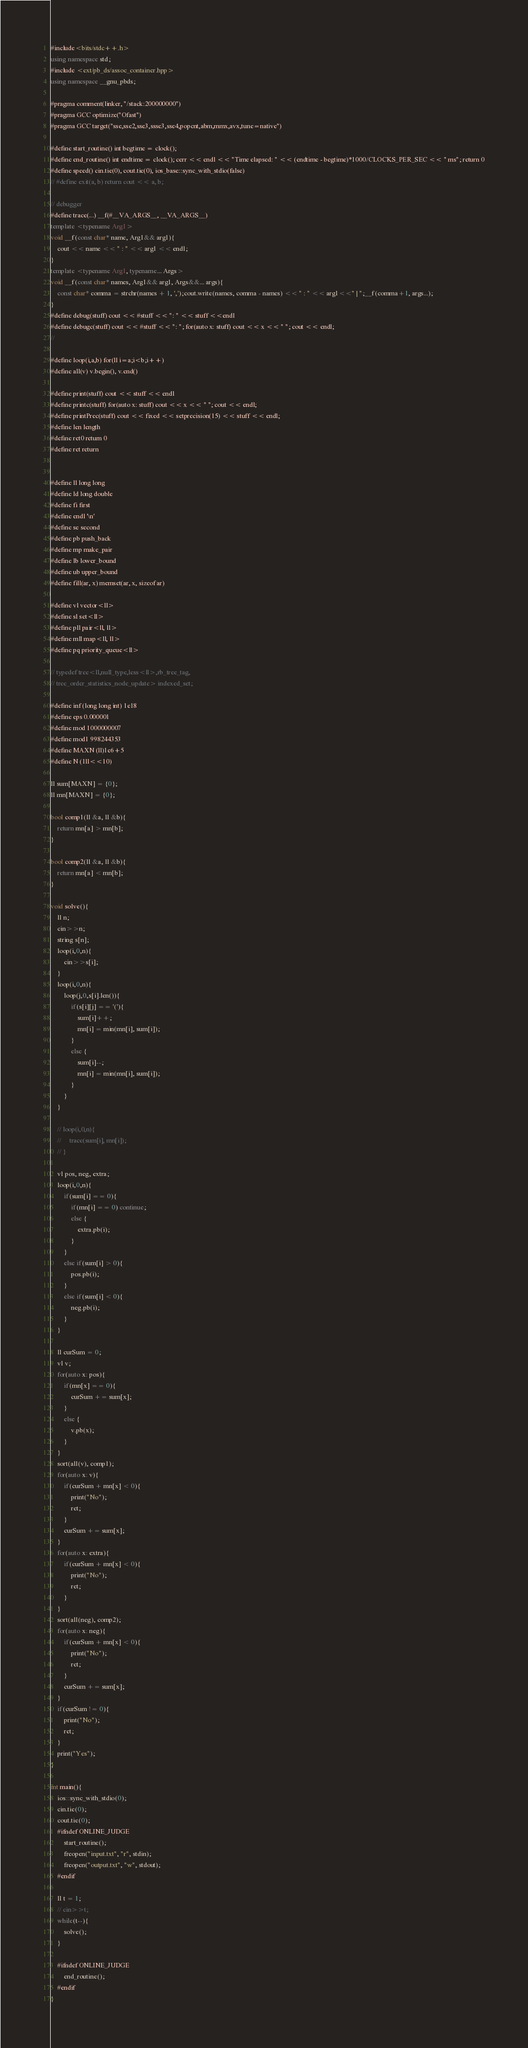<code> <loc_0><loc_0><loc_500><loc_500><_C++_>#include<bits/stdc++.h>
using namespace std;
#include <ext/pb_ds/assoc_container.hpp>
using namespace __gnu_pbds;
 
#pragma comment(linker, "/stack:200000000")
#pragma GCC optimize("Ofast")
#pragma GCC target("sse,sse2,sse3,ssse3,sse4,popcnt,abm,mmx,avx,tune=native")
 
#define start_routine() int begtime = clock();
#define end_routine() int endtime = clock(); cerr << endl << "Time elapsed: " << (endtime - begtime)*1000/CLOCKS_PER_SEC << " ms"; return 0
#define speed() cin.tie(0), cout.tie(0), ios_base::sync_with_stdio(false)
// #define exit(a, b) return cout << a, b;
 
// debugger
#define trace(...) __f(#__VA_ARGS__, __VA_ARGS__)
template <typename Arg1>
void __f(const char* name, Arg1&& arg1){
    cout << name << " : " << arg1 << endl;
}
template <typename Arg1, typename... Args>
void __f(const char* names, Arg1&& arg1, Args&&... args){
    const char* comma = strchr(names + 1, ',');cout.write(names, comma - names) << " : " << arg1<<" | ";__f(comma+1, args...);
}
#define debug(stuff) cout << #stuff << ": " << stuff <<endl
#define debugc(stuff) cout << #stuff << ": "; for(auto x: stuff) cout << x << " "; cout << endl;
// 
 
#define loop(i,a,b) for(ll i=a;i<b;i++)
#define all(v) v.begin(), v.end() 
 
#define print(stuff) cout << stuff << endl
#define printc(stuff) for(auto x: stuff) cout << x << " "; cout << endl;
#define printPrec(stuff) cout << fixed << setprecision(15) << stuff << endl;
#define len length
#define ret0 return 0
#define ret return 
 
 
#define ll long long
#define ld long double
#define fi first
#define endl '\n'
#define se second
#define pb push_back
#define mp make_pair
#define lb lower_bound
#define ub upper_bound
#define fill(ar, x) memset(ar, x, sizeof ar)
 
#define vl vector<ll> 
#define sl set<ll>
#define pll pair<ll, ll>
#define mll map<ll, ll> 
#define pq priority_queue<ll>
 
// typedef tree<ll,null_type,less<ll>,rb_tree_tag,
// tree_order_statistics_node_update> indexed_set;
 
#define inf (long long int) 1e18
#define eps 0.000001
#define mod 1000000007
#define mod1 998244353
#define MAXN (ll)1e6+5
#define N (1ll<<10)

ll sum[MAXN] = {0};
ll mn[MAXN] = {0};

bool comp1(ll &a, ll &b){
    return mn[a] > mn[b];
}

bool comp2(ll &a, ll &b){
    return mn[a] < mn[b];
}

void solve(){
    ll n;
    cin>>n;
    string s[n];
    loop(i,0,n){
        cin>>s[i];
    }
    loop(i,0,n){
        loop(j,0,s[i].len()){
            if(s[i][j] == '('){
                sum[i]++;
                mn[i] = min(mn[i], sum[i]);
            }
            else {
                sum[i]--;
                mn[i] = min(mn[i], sum[i]);
            }
        }
    }

    // loop(i,0,n){
    //     trace(sum[i], mn[i]);
    // }

    vl pos, neg, extra;
    loop(i,0,n){
        if(sum[i] == 0){
            if(mn[i] == 0) continue;
            else {
                extra.pb(i);
            }
        }
        else if(sum[i] > 0){
            pos.pb(i);
        }
        else if(sum[i] < 0){
            neg.pb(i);
        }
    }

    ll curSum = 0;
    vl v;
    for(auto x: pos){
        if(mn[x] == 0){
            curSum += sum[x];
        }
        else {
            v.pb(x);
        }
    }
    sort(all(v), comp1);
    for(auto x: v){
        if(curSum + mn[x] < 0){
            print("No");
            ret;
        }
        curSum += sum[x];
    }
    for(auto x: extra){
        if(curSum + mn[x] < 0){
            print("No");
            ret;
        }
    }
    sort(all(neg), comp2);
    for(auto x: neg){
        if(curSum + mn[x] < 0){
            print("No");
            ret;
        }
        curSum += sum[x];
    }
    if(curSum != 0){
        print("No");
        ret;
    }
    print("Yes");
}
 
int main(){
    ios::sync_with_stdio(0);
    cin.tie(0);
    cout.tie(0);
    #ifndef ONLINE_JUDGE
        start_routine();
        freopen("input.txt", "r", stdin);
        freopen("output.txt", "w", stdout);
    #endif
 
    ll t = 1;
    // cin>>t;
    while(t--){
        solve();
    }
        
    #ifndef ONLINE_JUDGE
        end_routine();
    #endif
}
</code> 